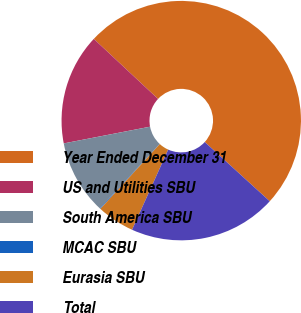Convert chart to OTSL. <chart><loc_0><loc_0><loc_500><loc_500><pie_chart><fcel>Year Ended December 31<fcel>US and Utilities SBU<fcel>South America SBU<fcel>MCAC SBU<fcel>Eurasia SBU<fcel>Total<nl><fcel>49.8%<fcel>15.01%<fcel>10.04%<fcel>0.1%<fcel>5.07%<fcel>19.98%<nl></chart> 